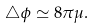<formula> <loc_0><loc_0><loc_500><loc_500>\bigtriangleup \phi \simeq 8 \pi \mu .</formula> 